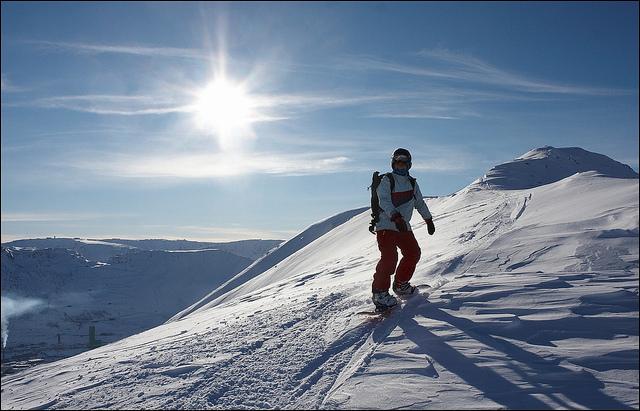Are the snowy mountains covered in sunlight?
Short answer required. Yes. Is the skiing or snowboarding?
Keep it brief. Snowboarding. Is it hot or cold?
Quick response, please. Cold. 